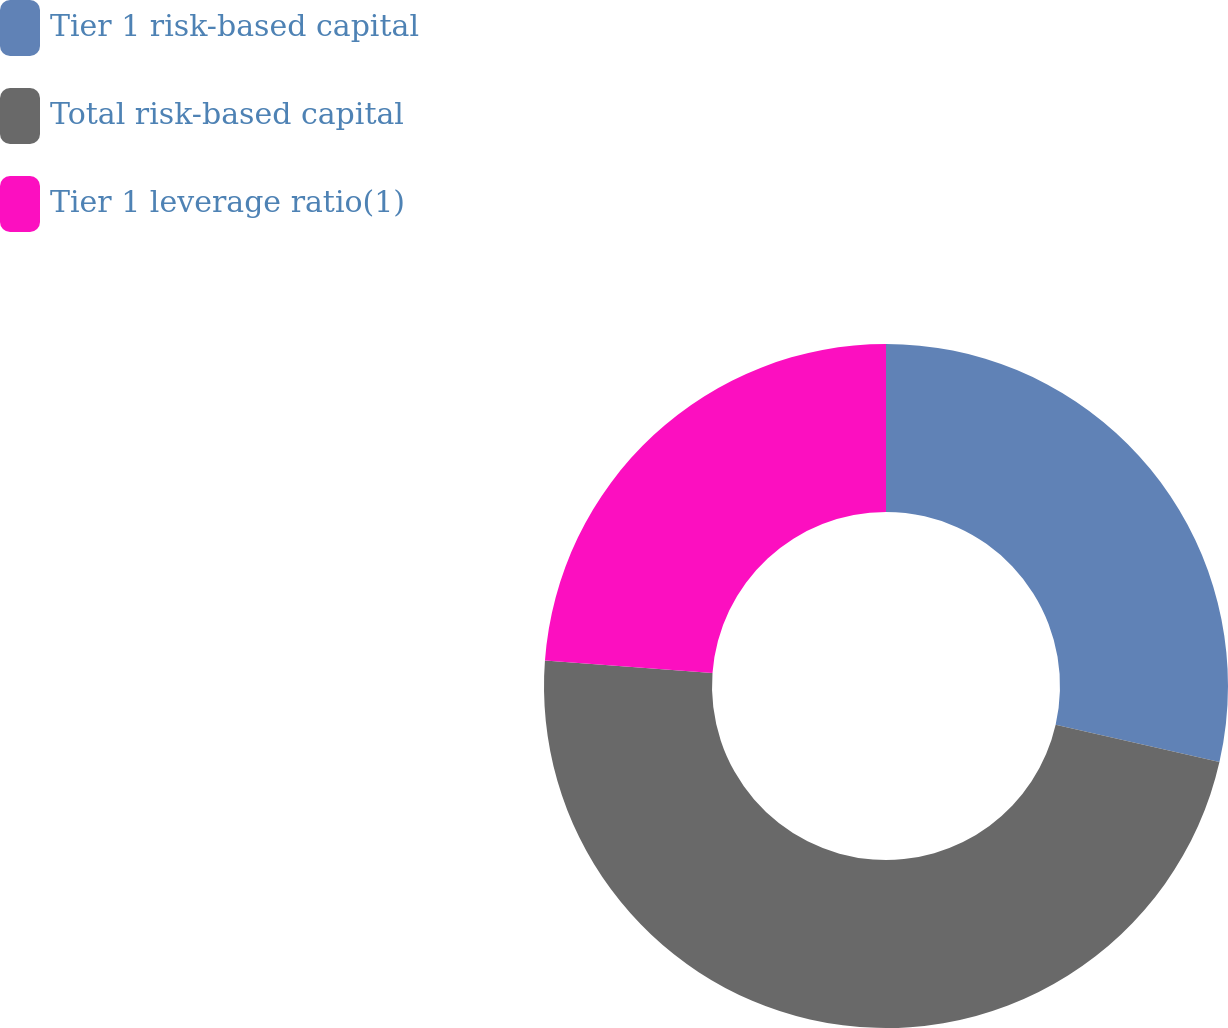Convert chart. <chart><loc_0><loc_0><loc_500><loc_500><pie_chart><fcel>Tier 1 risk-based capital<fcel>Total risk-based capital<fcel>Tier 1 leverage ratio(1)<nl><fcel>28.57%<fcel>47.62%<fcel>23.81%<nl></chart> 